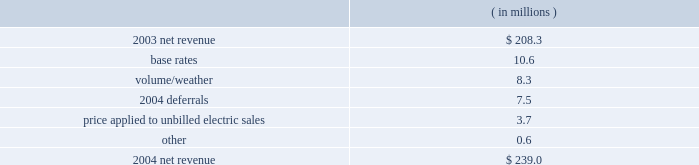Entergy new orleans , inc .
Management's financial discussion and analysis results of operations net income ( loss ) 2004 compared to 2003 net income increased $ 20.2 million primarily due to higher net revenue .
2003 compared to 2002 entergy new orleans had net income of $ 7.9 million in 2003 compared to a net loss in 2002 .
The increase was due to higher net revenue and lower interest expense , partially offset by higher other operation and maintenance expenses and depreciation and amortization expenses .
Net revenue 2004 compared to 2003 net revenue , which is entergy new orleans' measure of gross margin , consists of operating revenues net of : 1 ) fuel , fuel-related , and purchased power expenses and 2 ) other regulatory credits .
Following is an analysis of the change in net revenue comparing 2004 to 2003. .
The increase in base rates was effective june 2003 .
The rate increase is discussed in note 2 to the domestic utility companies and system energy financial statements .
The volume/weather variance is primarily due to increased billed electric usage of 162 gwh in the industrial service sector .
The increase was partially offset by milder weather in the residential and commercial sectors .
The 2004 deferrals variance is due to the deferral of voluntary severance plan and fossil plant maintenance expenses in accordance with a stipulation approved by the city council in august 2004 .
The stipulation allows for the recovery of these costs through amortization of a regulatory asset .
The voluntary severance plan and fossil plant maintenance expenses are being amortized over a five-year period that became effective january 2004 and january 2003 , respectively .
The formula rate plan is discussed in note 2 to the domestic utility companies and system energy financial statements .
The price applied to unbilled electric sales variance is due to an increase in the fuel price applied to unbilled sales. .
What is the percent change in net revenue from 2003 to 2004? 
Computations: ((239.0 - 208.3) / 208.3)
Answer: 0.14738. 